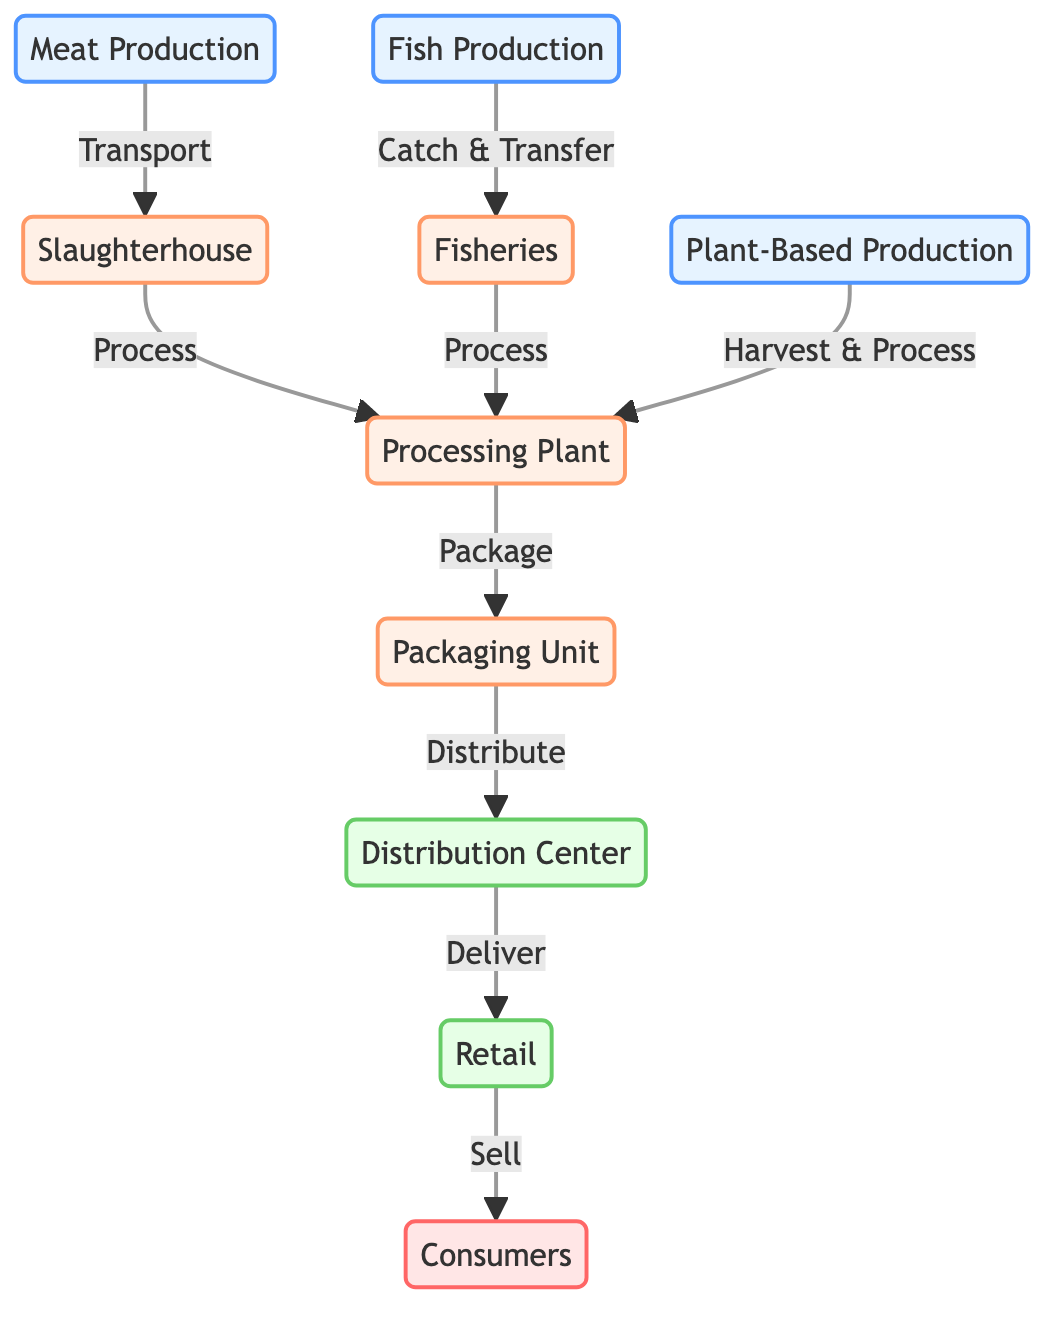What are the three main types of protein production? The diagram clearly lists three types of protein production: meat production, fish production, and plant-based production. These are labeled as distinct nodes in the production category.
Answer: meat production, fish production, plant-based production What follows the slaughterhouse in the processing sequence? According to the diagram, after the slaughterhouse, the next step in the processing sequence is the processing plant, as indicated by the directed edge flowing from the slaughterhouse to the processing plant.
Answer: processing plant How many processing steps are shown in the diagram? The diagram includes three processing steps, which are the slaughterhouse, fisheries, and the processing plant. Each is a discrete node leading to further processing.
Answer: 3 Which type of production has a direct connection to fisheries? The fish production node has a direct connection to the fisheries node, demonstrating that fish production is processed through fisheries before moving further in the chain.
Answer: fish production Where do consumers receive their products from? The consumers node receives products from the retail node, which is indicated by a directed edge flowing from retail to consumers in the distribution chain.
Answer: retail What is the role of the packaging unit in the supply chain? The packaging unit appears in the processing sequence, serving the purpose of packaging products after they have been processed, as indicated by the directed edge from the processing plant to the packaging unit.
Answer: packaging How many nodes are there in total in the diagram? Counting all the distinct nodes shown in the diagram for production, processing, distribution, and consumers, there are a total of 10 nodes.
Answer: 10 Which node in the diagram represents the initial step of meat production? The meat production node is the initial step in the cycle of meat supply chain, marked as the beginning point leading to the slaughterhouse.
Answer: meat production How are plant-based products processed according to the diagram? Plant-based products are harvested and processed at the processing plant, as shown by the link between the plant production node and the processing plant node.
Answer: processing plant 